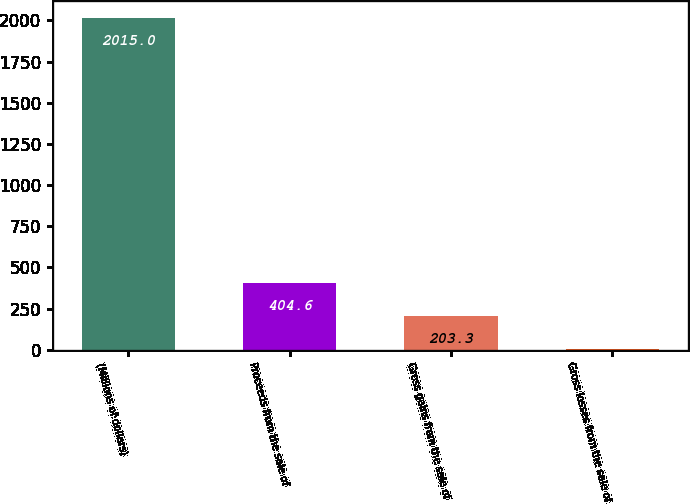<chart> <loc_0><loc_0><loc_500><loc_500><bar_chart><fcel>(Millions of dollars)<fcel>Proceeds from the sale of<fcel>Gross gains from the sale of<fcel>Gross losses from the sale of<nl><fcel>2015<fcel>404.6<fcel>203.3<fcel>2<nl></chart> 